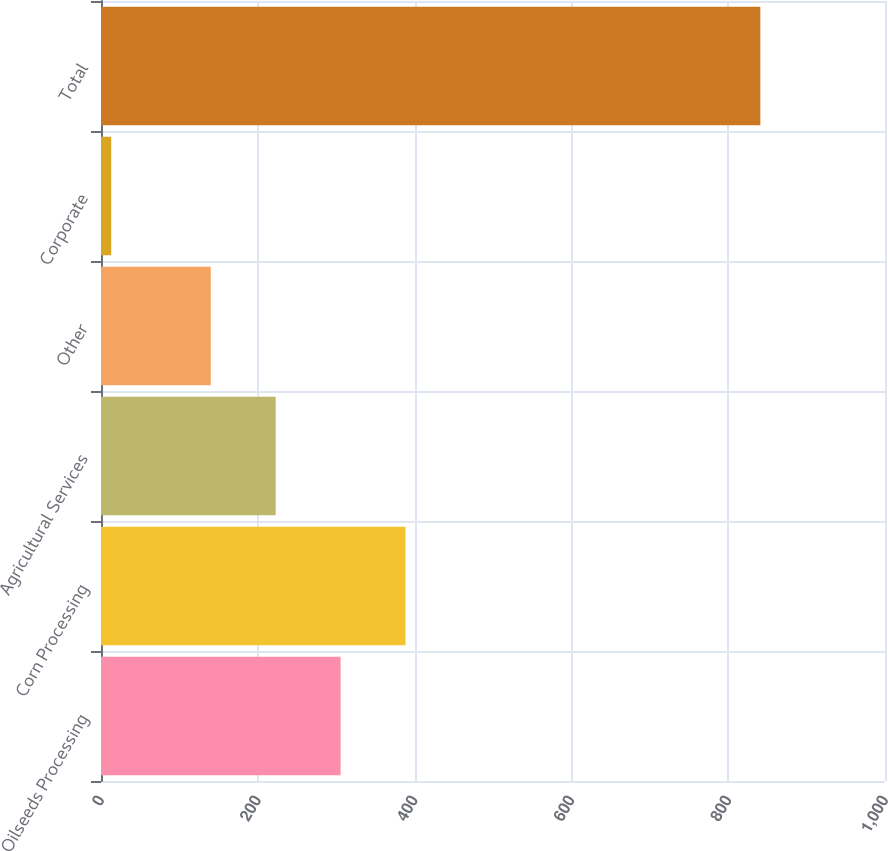Convert chart. <chart><loc_0><loc_0><loc_500><loc_500><bar_chart><fcel>Oilseeds Processing<fcel>Corn Processing<fcel>Agricultural Services<fcel>Other<fcel>Corporate<fcel>Total<nl><fcel>305.6<fcel>388.4<fcel>222.8<fcel>140<fcel>13<fcel>841<nl></chart> 